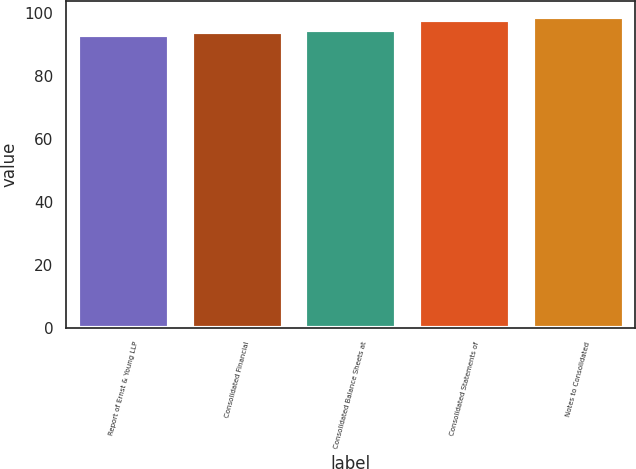Convert chart to OTSL. <chart><loc_0><loc_0><loc_500><loc_500><bar_chart><fcel>Report of Ernst & Young LLP<fcel>Consolidated Financial<fcel>Consolidated Balance Sheets at<fcel>Consolidated Statements of<fcel>Notes to Consolidated<nl><fcel>93<fcel>94<fcel>94.6<fcel>98<fcel>99<nl></chart> 